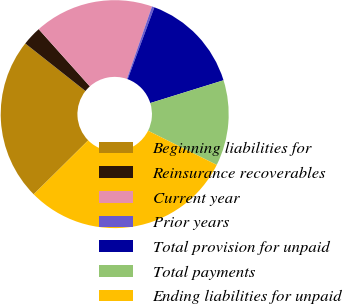<chart> <loc_0><loc_0><loc_500><loc_500><pie_chart><fcel>Beginning liabilities for<fcel>Reinsurance recoverables<fcel>Current year<fcel>Prior years<fcel>Total provision for unpaid<fcel>Total payments<fcel>Ending liabilities for unpaid<nl><fcel>23.07%<fcel>2.74%<fcel>16.93%<fcel>0.35%<fcel>14.54%<fcel>12.15%<fcel>30.23%<nl></chart> 